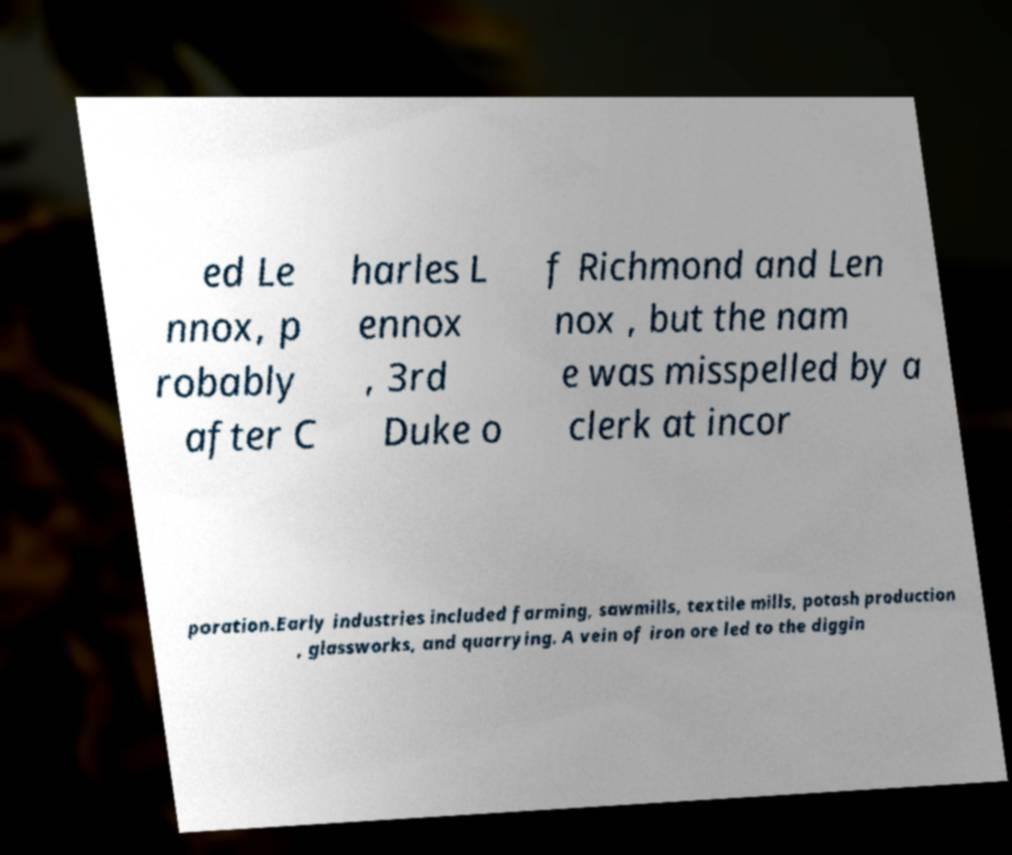For documentation purposes, I need the text within this image transcribed. Could you provide that? ed Le nnox, p robably after C harles L ennox , 3rd Duke o f Richmond and Len nox , but the nam e was misspelled by a clerk at incor poration.Early industries included farming, sawmills, textile mills, potash production , glassworks, and quarrying. A vein of iron ore led to the diggin 